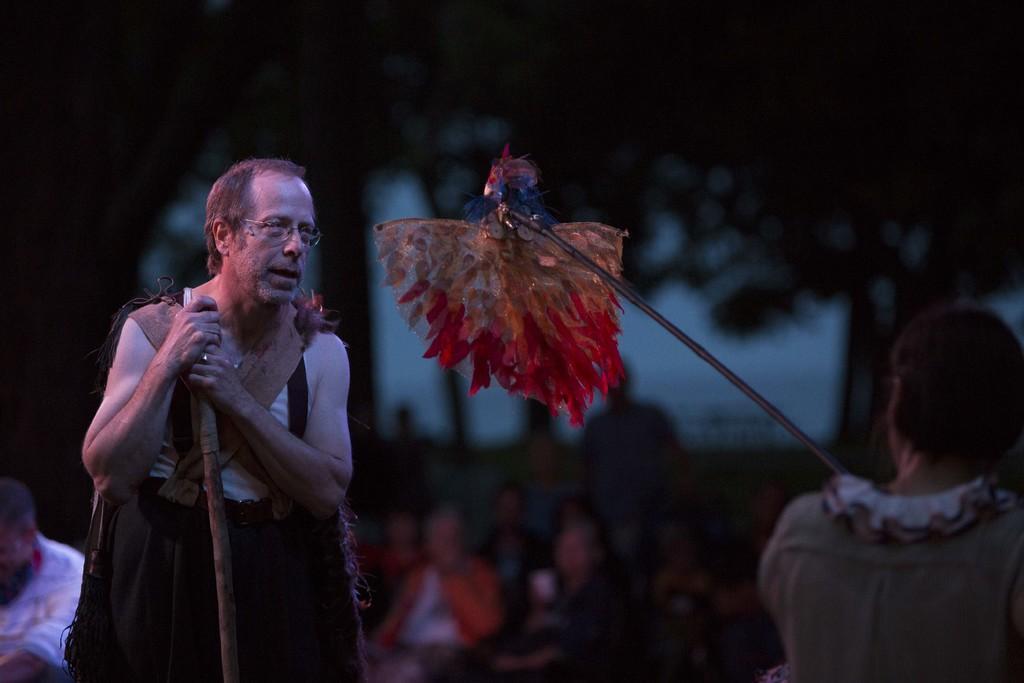Could you give a brief overview of what you see in this image? In this image, we can see few people. Here a person is holding a stick and wearing glasses. In the middle of the image, we can see a stick with some object. Background there is a blur view. Here we can see trees, few people. 